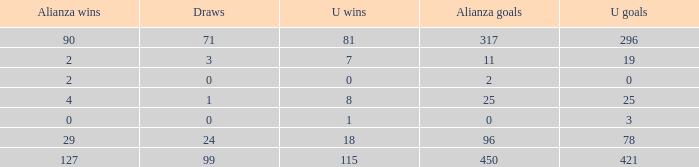What is the sum of Alianza Wins, when Alianza Goals is "317, and when U Goals is greater than 296? None. 